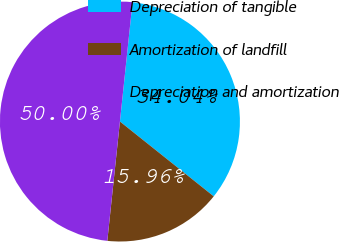<chart> <loc_0><loc_0><loc_500><loc_500><pie_chart><fcel>Depreciation of tangible<fcel>Amortization of landfill<fcel>Depreciation and amortization<nl><fcel>34.04%<fcel>15.96%<fcel>50.0%<nl></chart> 